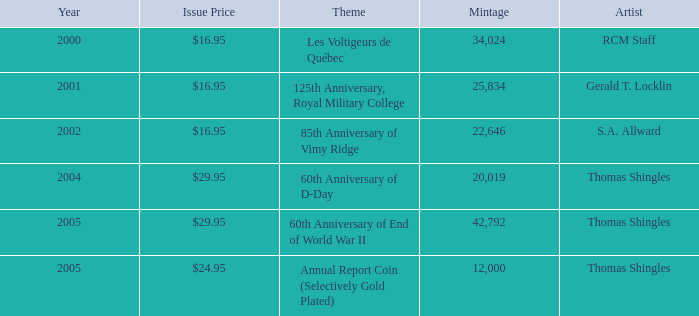What year was S.A. Allward's theme that had an issue price of $16.95 released? 2002.0. 